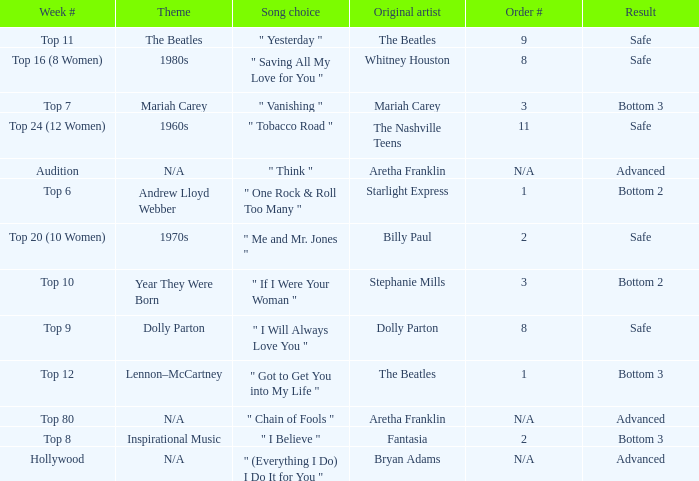Can you give me this table as a dict? {'header': ['Week #', 'Theme', 'Song choice', 'Original artist', 'Order #', 'Result'], 'rows': [['Top 11', 'The Beatles', '" Yesterday "', 'The Beatles', '9', 'Safe'], ['Top 16 (8 Women)', '1980s', '" Saving All My Love for You "', 'Whitney Houston', '8', 'Safe'], ['Top 7', 'Mariah Carey', '" Vanishing "', 'Mariah Carey', '3', 'Bottom 3'], ['Top 24 (12 Women)', '1960s', '" Tobacco Road "', 'The Nashville Teens', '11', 'Safe'], ['Audition', 'N/A', '" Think "', 'Aretha Franklin', 'N/A', 'Advanced'], ['Top 6', 'Andrew Lloyd Webber', '" One Rock & Roll Too Many "', 'Starlight Express', '1', 'Bottom 2'], ['Top 20 (10 Women)', '1970s', '" Me and Mr. Jones "', 'Billy Paul', '2', 'Safe'], ['Top 10', 'Year They Were Born', '" If I Were Your Woman "', 'Stephanie Mills', '3', 'Bottom 2'], ['Top 9', 'Dolly Parton', '" I Will Always Love You "', 'Dolly Parton', '8', 'Safe'], ['Top 12', 'Lennon–McCartney', '" Got to Get You into My Life "', 'The Beatles', '1', 'Bottom 3'], ['Top 80', 'N/A', '" Chain of Fools "', 'Aretha Franklin', 'N/A', 'Advanced'], ['Top 8', 'Inspirational Music', '" I Believe "', 'Fantasia', '2', 'Bottom 3'], ['Hollywood', 'N/A', '" (Everything I Do) I Do It for You "', 'Bryan Adams', 'N/A', 'Advanced']]} Name the week number for andrew lloyd webber Top 6. 